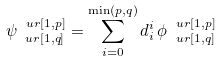Convert formula to latex. <formula><loc_0><loc_0><loc_500><loc_500>\psi ^ { \ u r { [ 1 , p ] } } _ { \ u r { [ 1 , q ] } } = \sum _ { i = 0 } ^ { \min ( p , q ) } d _ { i } ^ { i } \, \phi ^ { \ u r { [ 1 , p ] } } _ { \ u r { [ 1 , q ] } }</formula> 